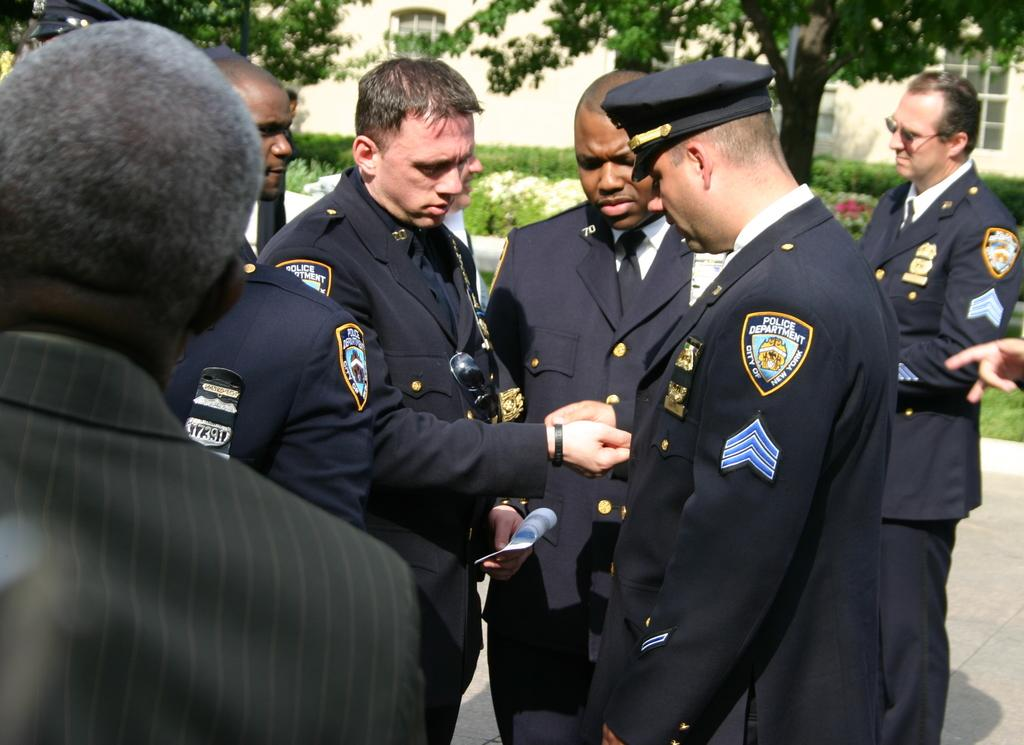How many persons are visible in the image? There are persons standing in the image. What are two of the persons doing in the image? Two persons are holding objects. What can be seen in the background of the image? There are plants, flowers, trees, and a building in the background of the image. Can you tell me how many deer are visible in the image? There are no deer present in the image. What type of light source is illuminating the persons in the image? The provided facts do not mention any light source; we can only see the persons and the objects they are holding. 